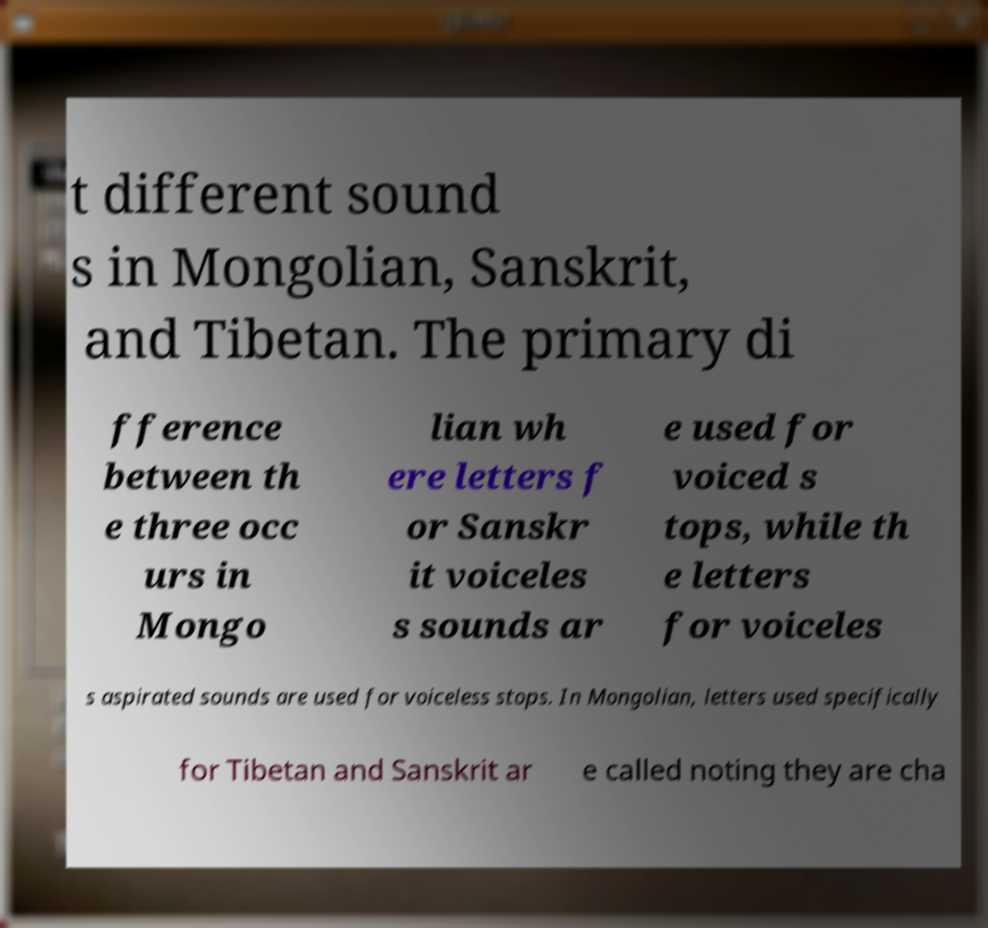I need the written content from this picture converted into text. Can you do that? t different sound s in Mongolian, Sanskrit, and Tibetan. The primary di fference between th e three occ urs in Mongo lian wh ere letters f or Sanskr it voiceles s sounds ar e used for voiced s tops, while th e letters for voiceles s aspirated sounds are used for voiceless stops. In Mongolian, letters used specifically for Tibetan and Sanskrit ar e called noting they are cha 